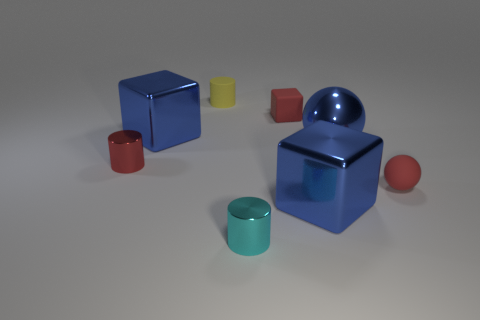There is a rubber block that is the same size as the cyan metallic thing; what color is it? red 